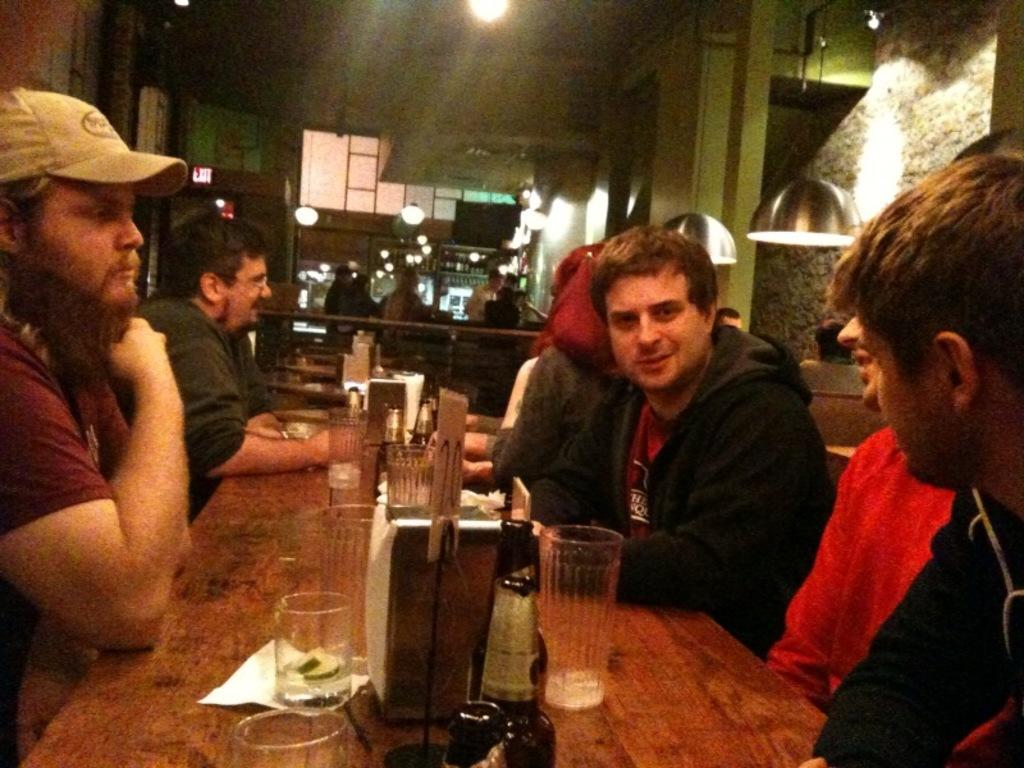What type of furniture is present in the image? There is a table in the image. What items can be seen on the table? There are bottles, glasses, and tissue paper on the table. What can be seen in the background of the image? There is a wall visible in the image. Are there any people in the image? Yes, there are persons in the image. What type of lighting is present in the image? There are lights visible in the image. What type of pleasure can be seen on the throne in the image? There is no throne present in the image, and therefore no pleasure can be observed. 